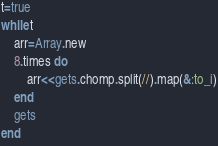<code> <loc_0><loc_0><loc_500><loc_500><_Ruby_>t=true
while t
    arr=Array.new
    8.times do
        arr<<gets.chomp.split(//).map(&:to_i)
    end
    gets
end</code> 